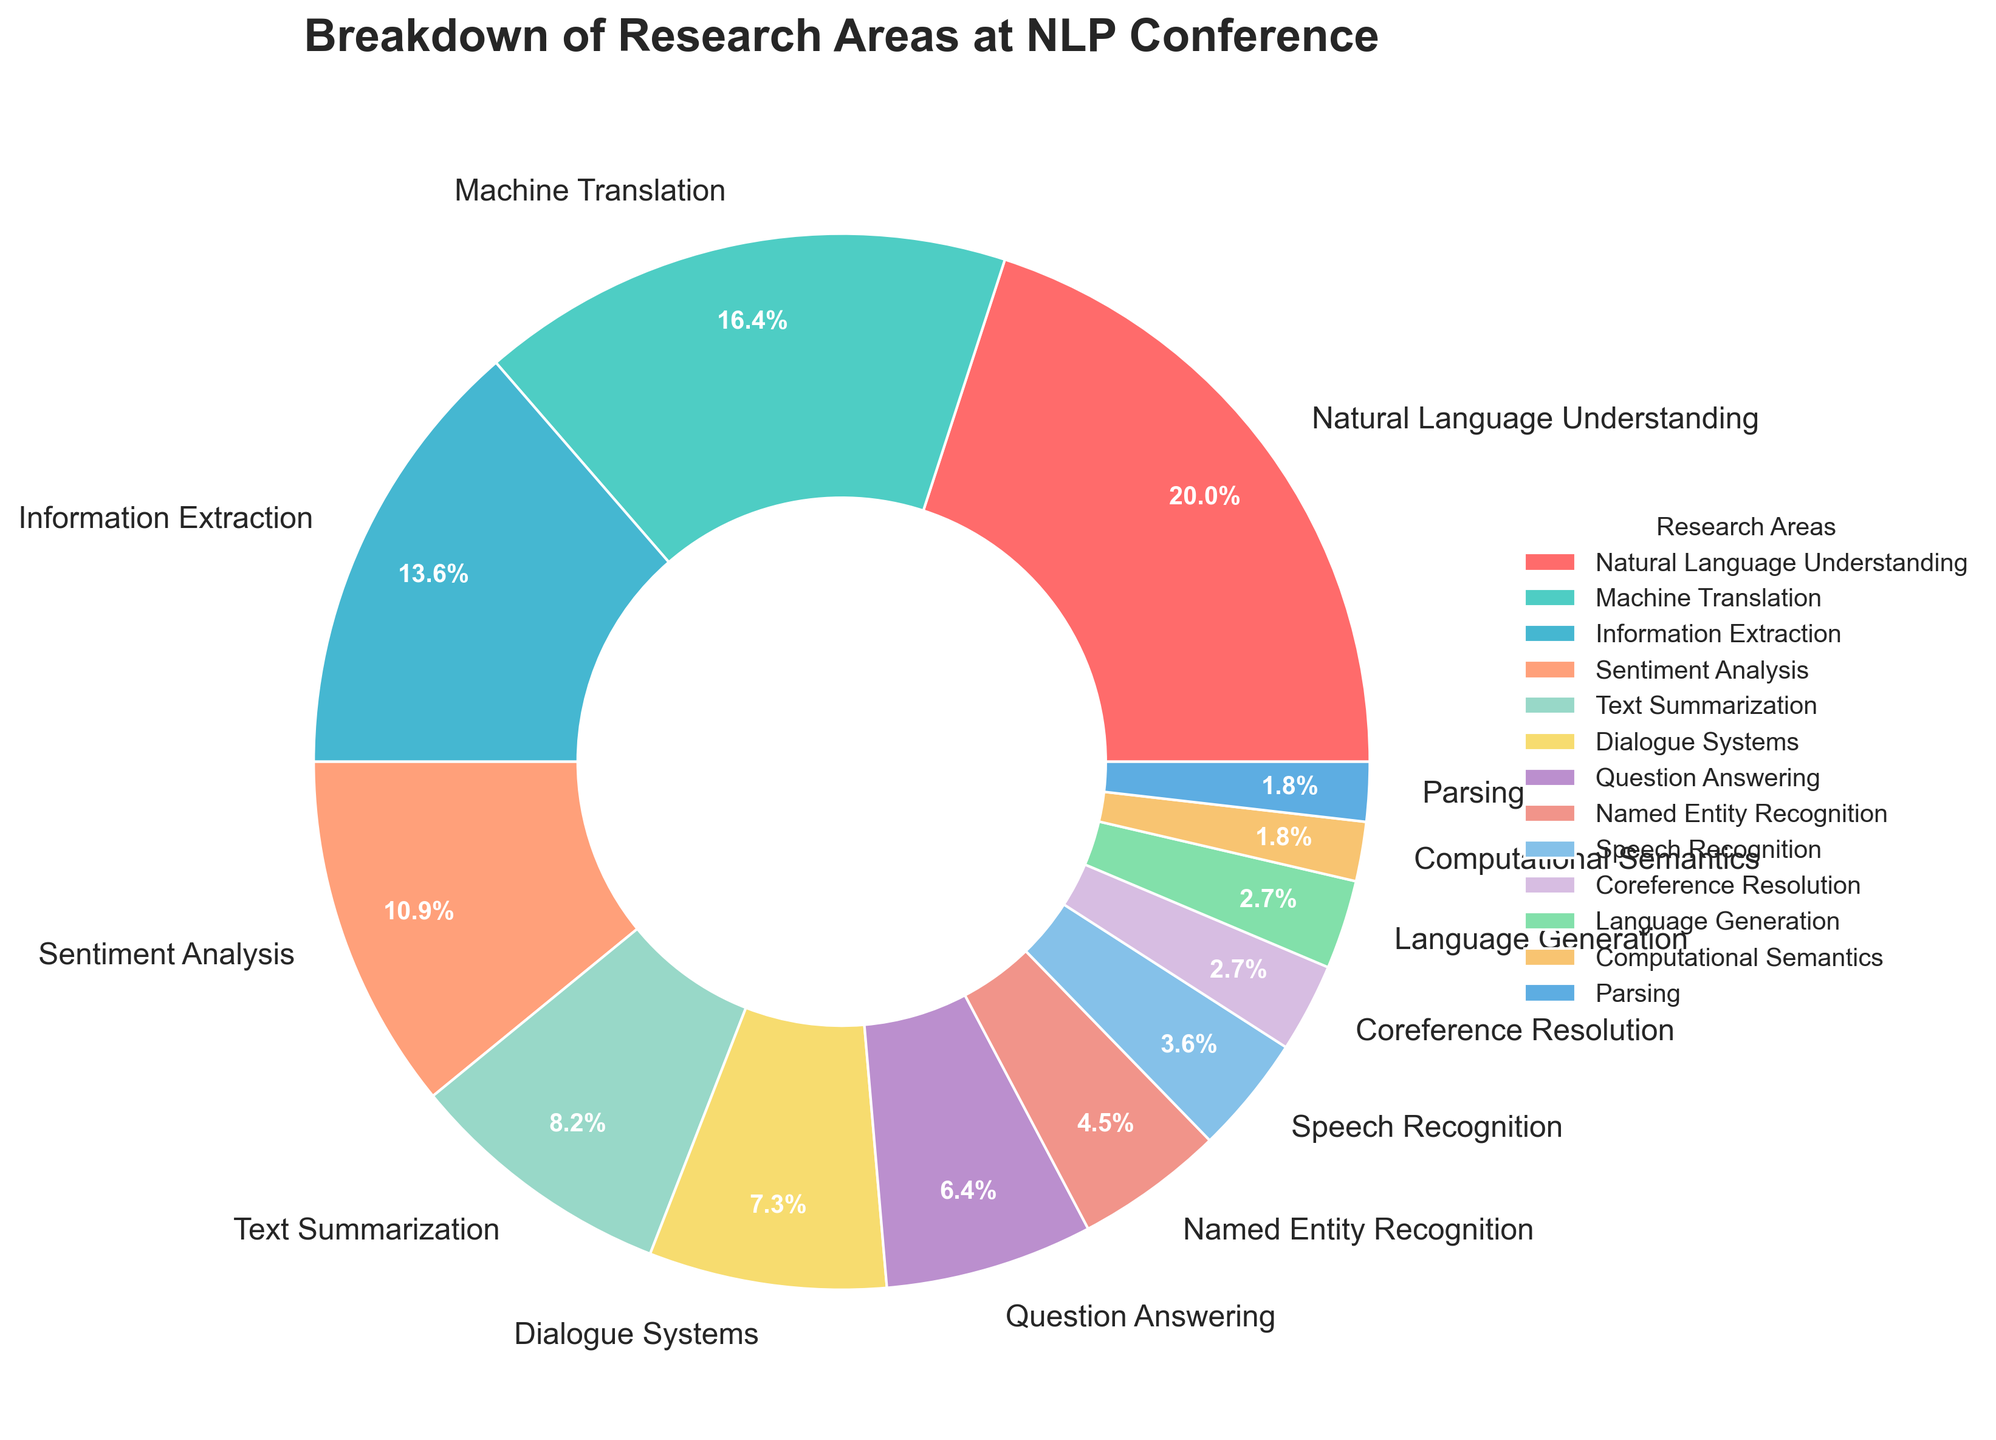What research area has the largest percentage at the NLP conference? The segment labeled "Natural Language Understanding" is the largest in the pie chart.
Answer: Natural Language Understanding What's the combined percentage of Machine Translation and Information Extraction? By adding the percentages for Machine Translation (18%) and Information Extraction (15%), we get a total of 33%.
Answer: 33% Which research area has a higher percentage, Text Summarization or Dialogue Systems? Text Summarization has a 9% share while Dialogue Systems has an 8% share. Text Summarization is higher.
Answer: Text Summarization What is the total percentage of the three smallest categories? The smallest categories are Parsing (2%), Computational Semantics (2%), and Language Generation (3%). Adding them up, we get 2% + 2% + 3% = 7%.
Answer: 7% Which research area is represented by light blue color? The light blue color corresponds to the segment labeled "Machine Translation."
Answer: Machine Translation How much larger is the percentage of Natural Language Understanding compared to Sentiment Analysis? Natural Language Understanding has a percentage of 22% while Sentiment Analysis has 12%. The difference is 22% - 12% = 10%.
Answer: 10% What research areas have percentages less than 5%? The areas with percentages less than 5% are Named Entity Recognition (5%), Speech Recognition (4%), Coreference Resolution (3%), Language Generation (3%), Computational Semantics (2%), and Parsing (2%).
Answer: Named Entity Recognition, Speech Recognition, Coreference Resolution, Language Generation, Computational Semantics, Parsing How does the percentage of Question Answering compare to that of Natural Language Understanding? Question Answering has 7% while Natural Language Understanding has 22%. Natural Language Understanding has a higher percentage.
Answer: Natural Language Understanding What is the average percentage of the three largest research areas? The three largest research areas are Natural Language Understanding (22%), Machine Translation (18%), and Information Extraction (15%). Their averages are (22% + 18% + 15%) / 3 = 18.33%.
Answer: 18.33% 